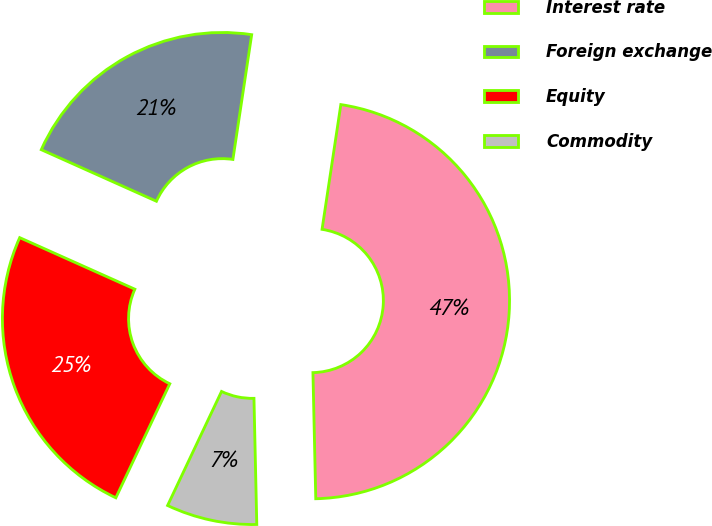Convert chart to OTSL. <chart><loc_0><loc_0><loc_500><loc_500><pie_chart><fcel>Interest rate<fcel>Foreign exchange<fcel>Equity<fcel>Commodity<nl><fcel>47.27%<fcel>20.68%<fcel>24.67%<fcel>7.39%<nl></chart> 